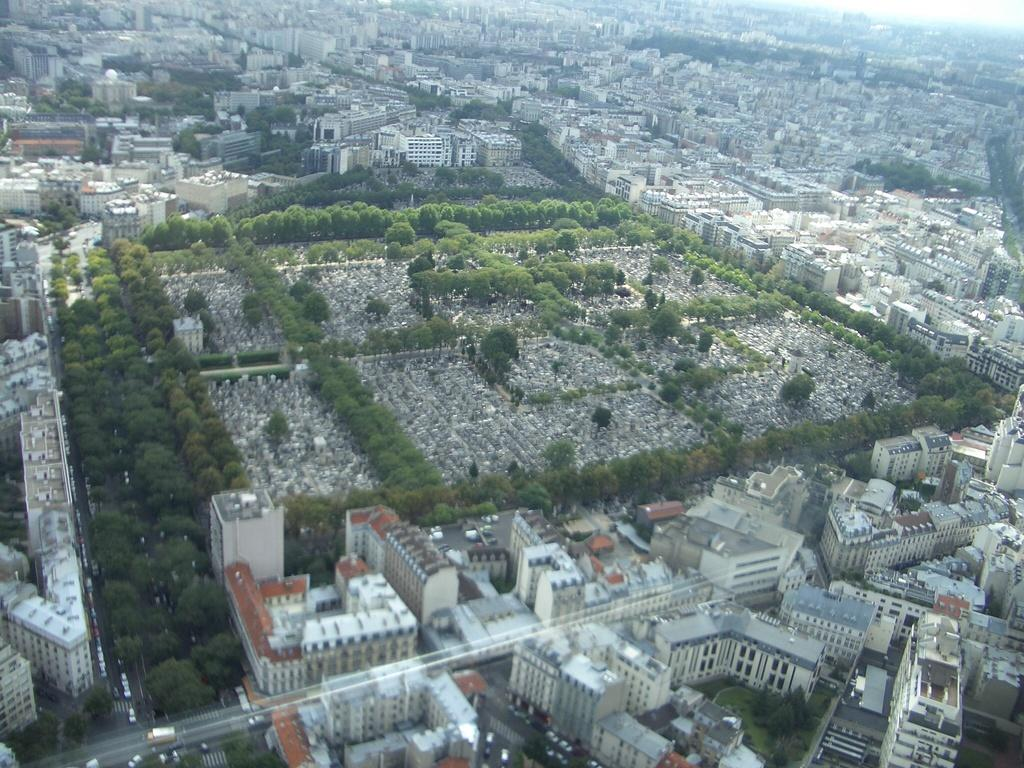What type of view is shown in the image? The image is an aerial view. What structures can be seen from this perspective? There are many buildings visible in the image. Are there any natural elements present in the image? Yes, there are trees in the image. What is happening on the roads in the image? Vehicles are moving on the road in the image. How many dogs can be seen playing in the trees in the image? There are no dogs present in the image; it features an aerial view of buildings, trees, and roads. What color is the robin perched on the fifth building in the image? There is no robin present in the image, and the factual information provided does not mention any specific buildings or their colors. 